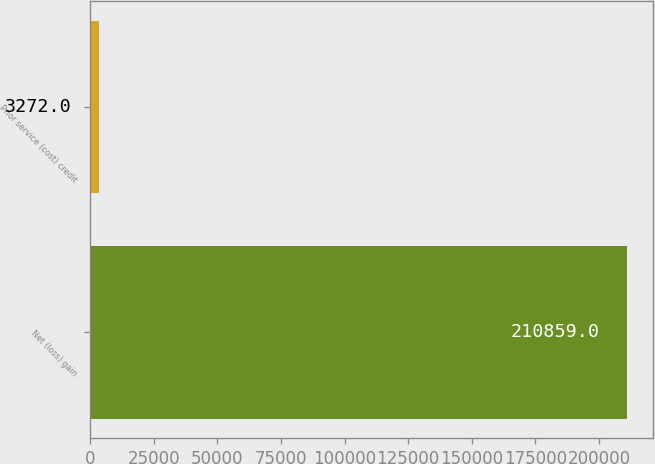Convert chart to OTSL. <chart><loc_0><loc_0><loc_500><loc_500><bar_chart><fcel>Net (loss) gain<fcel>Prior service (cost) credit<nl><fcel>210859<fcel>3272<nl></chart> 